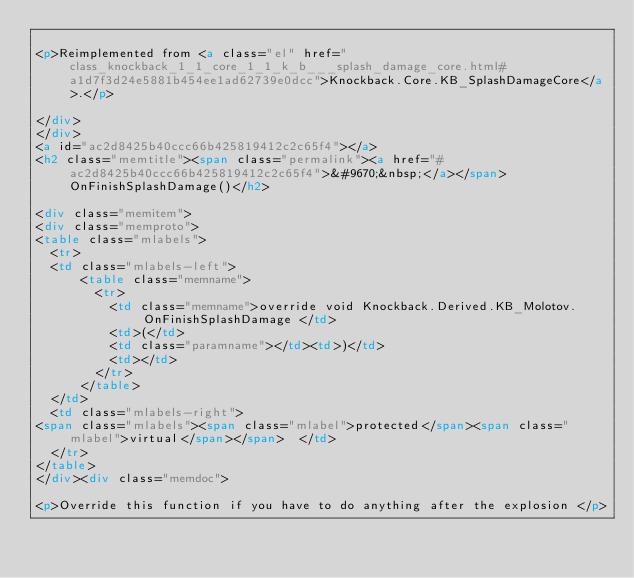Convert code to text. <code><loc_0><loc_0><loc_500><loc_500><_HTML_>
<p>Reimplemented from <a class="el" href="class_knockback_1_1_core_1_1_k_b___splash_damage_core.html#a1d7f3d24e5881b454ee1ad62739e0dcc">Knockback.Core.KB_SplashDamageCore</a>.</p>

</div>
</div>
<a id="ac2d8425b40ccc66b425819412c2c65f4"></a>
<h2 class="memtitle"><span class="permalink"><a href="#ac2d8425b40ccc66b425819412c2c65f4">&#9670;&nbsp;</a></span>OnFinishSplashDamage()</h2>

<div class="memitem">
<div class="memproto">
<table class="mlabels">
  <tr>
  <td class="mlabels-left">
      <table class="memname">
        <tr>
          <td class="memname">override void Knockback.Derived.KB_Molotov.OnFinishSplashDamage </td>
          <td>(</td>
          <td class="paramname"></td><td>)</td>
          <td></td>
        </tr>
      </table>
  </td>
  <td class="mlabels-right">
<span class="mlabels"><span class="mlabel">protected</span><span class="mlabel">virtual</span></span>  </td>
  </tr>
</table>
</div><div class="memdoc">

<p>Override this function if you have to do anything after the explosion </p>
</code> 